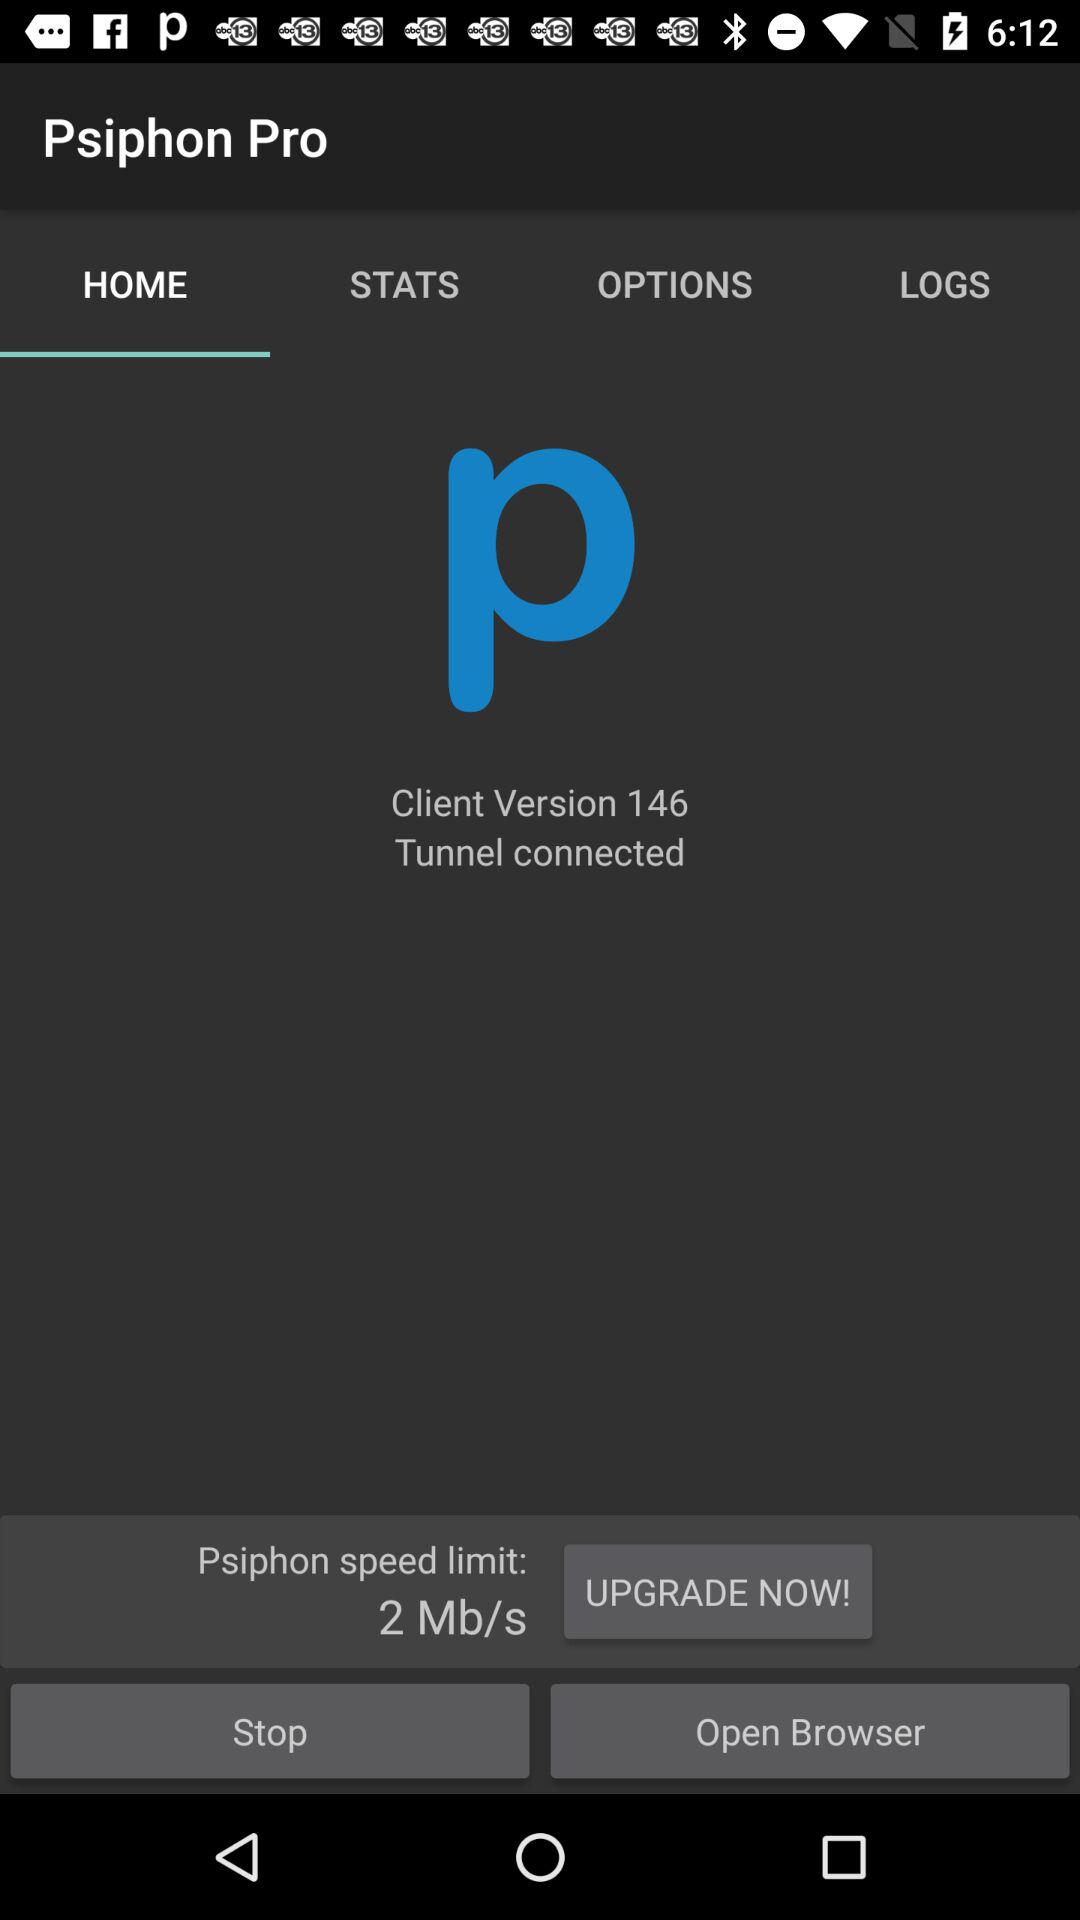What is the "Psiphon speed limit"? The "Psiphon speed limit" is 2 Mb/s. 